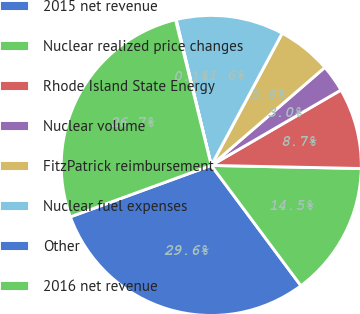Convert chart to OTSL. <chart><loc_0><loc_0><loc_500><loc_500><pie_chart><fcel>2015 net revenue<fcel>Nuclear realized price changes<fcel>Rhode Island State Energy<fcel>Nuclear volume<fcel>FitzPatrick reimbursement<fcel>Nuclear fuel expenses<fcel>Other<fcel>2016 net revenue<nl><fcel>29.62%<fcel>14.48%<fcel>8.71%<fcel>2.95%<fcel>5.83%<fcel>11.6%<fcel>0.07%<fcel>26.74%<nl></chart> 